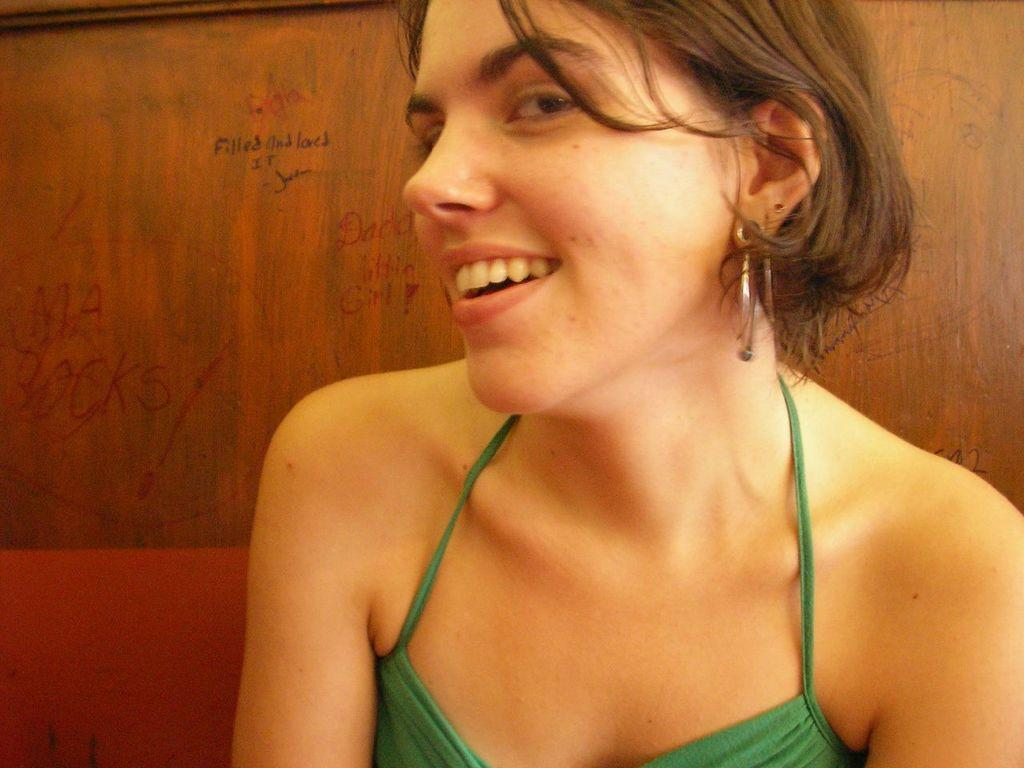Who is the main subject in the picture? There is a girl in the picture. What is the girl wearing? The girl is wearing a green top. What is the girl's facial expression in the picture? The girl is smiling. What is the girl doing in the picture? The girl is giving a pose into the camera. What can be seen in the background of the picture? There is a wooden panel wall in the background of the picture. What type of stick can be seen in the girl's hand in the image? There is no stick present in the girl's hand or in the image. How does the girl wash her clothes in the image? There is no indication of the girl washing clothes in the image. 